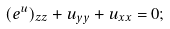<formula> <loc_0><loc_0><loc_500><loc_500>( e ^ { u } ) _ { z z } + u _ { y y } + u _ { x x } = 0 ;</formula> 